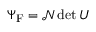Convert formula to latex. <formula><loc_0><loc_0><loc_500><loc_500>\Psi _ { F } = { \mathcal { N } } \det U</formula> 